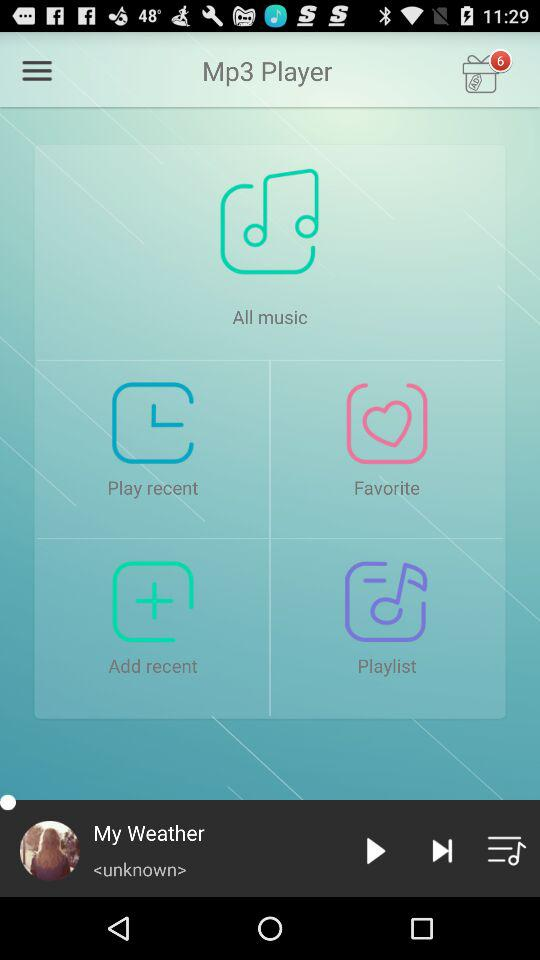Which song is paused? The song is "My Weather". 